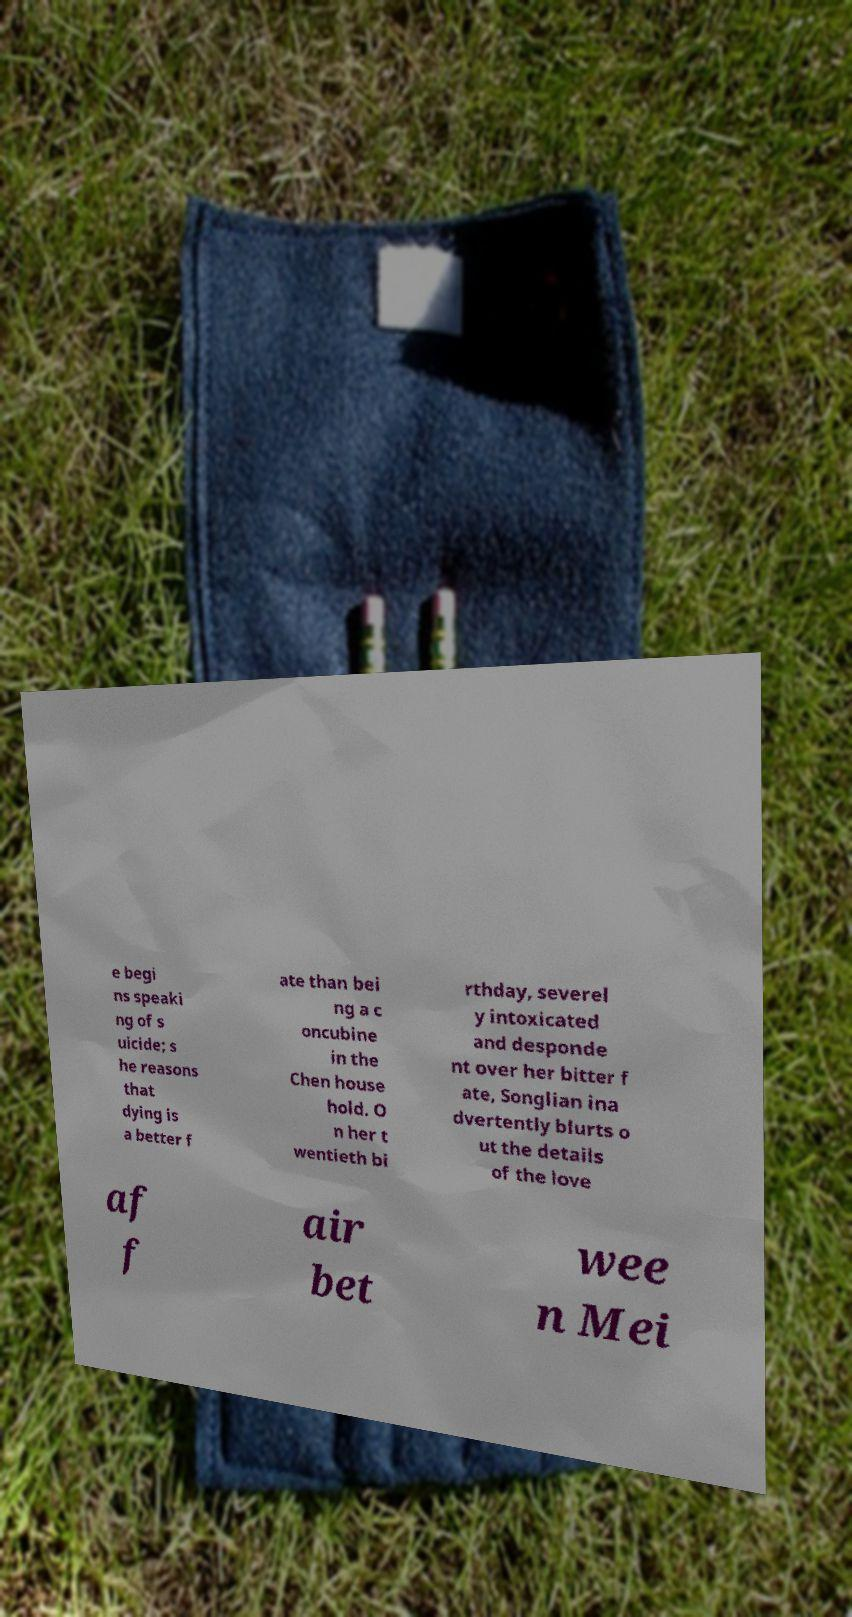Can you read and provide the text displayed in the image?This photo seems to have some interesting text. Can you extract and type it out for me? e begi ns speaki ng of s uicide; s he reasons that dying is a better f ate than bei ng a c oncubine in the Chen house hold. O n her t wentieth bi rthday, severel y intoxicated and desponde nt over her bitter f ate, Songlian ina dvertently blurts o ut the details of the love af f air bet wee n Mei 